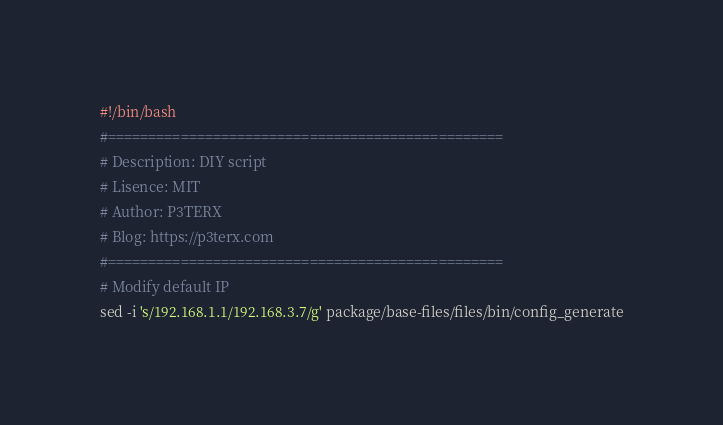Convert code to text. <code><loc_0><loc_0><loc_500><loc_500><_Bash_>#!/bin/bash
#=================================================
# Description: DIY script
# Lisence: MIT
# Author: P3TERX
# Blog: https://p3terx.com
#=================================================
# Modify default IP
sed -i 's/192.168.1.1/192.168.3.7/g' package/base-files/files/bin/config_generate
</code> 